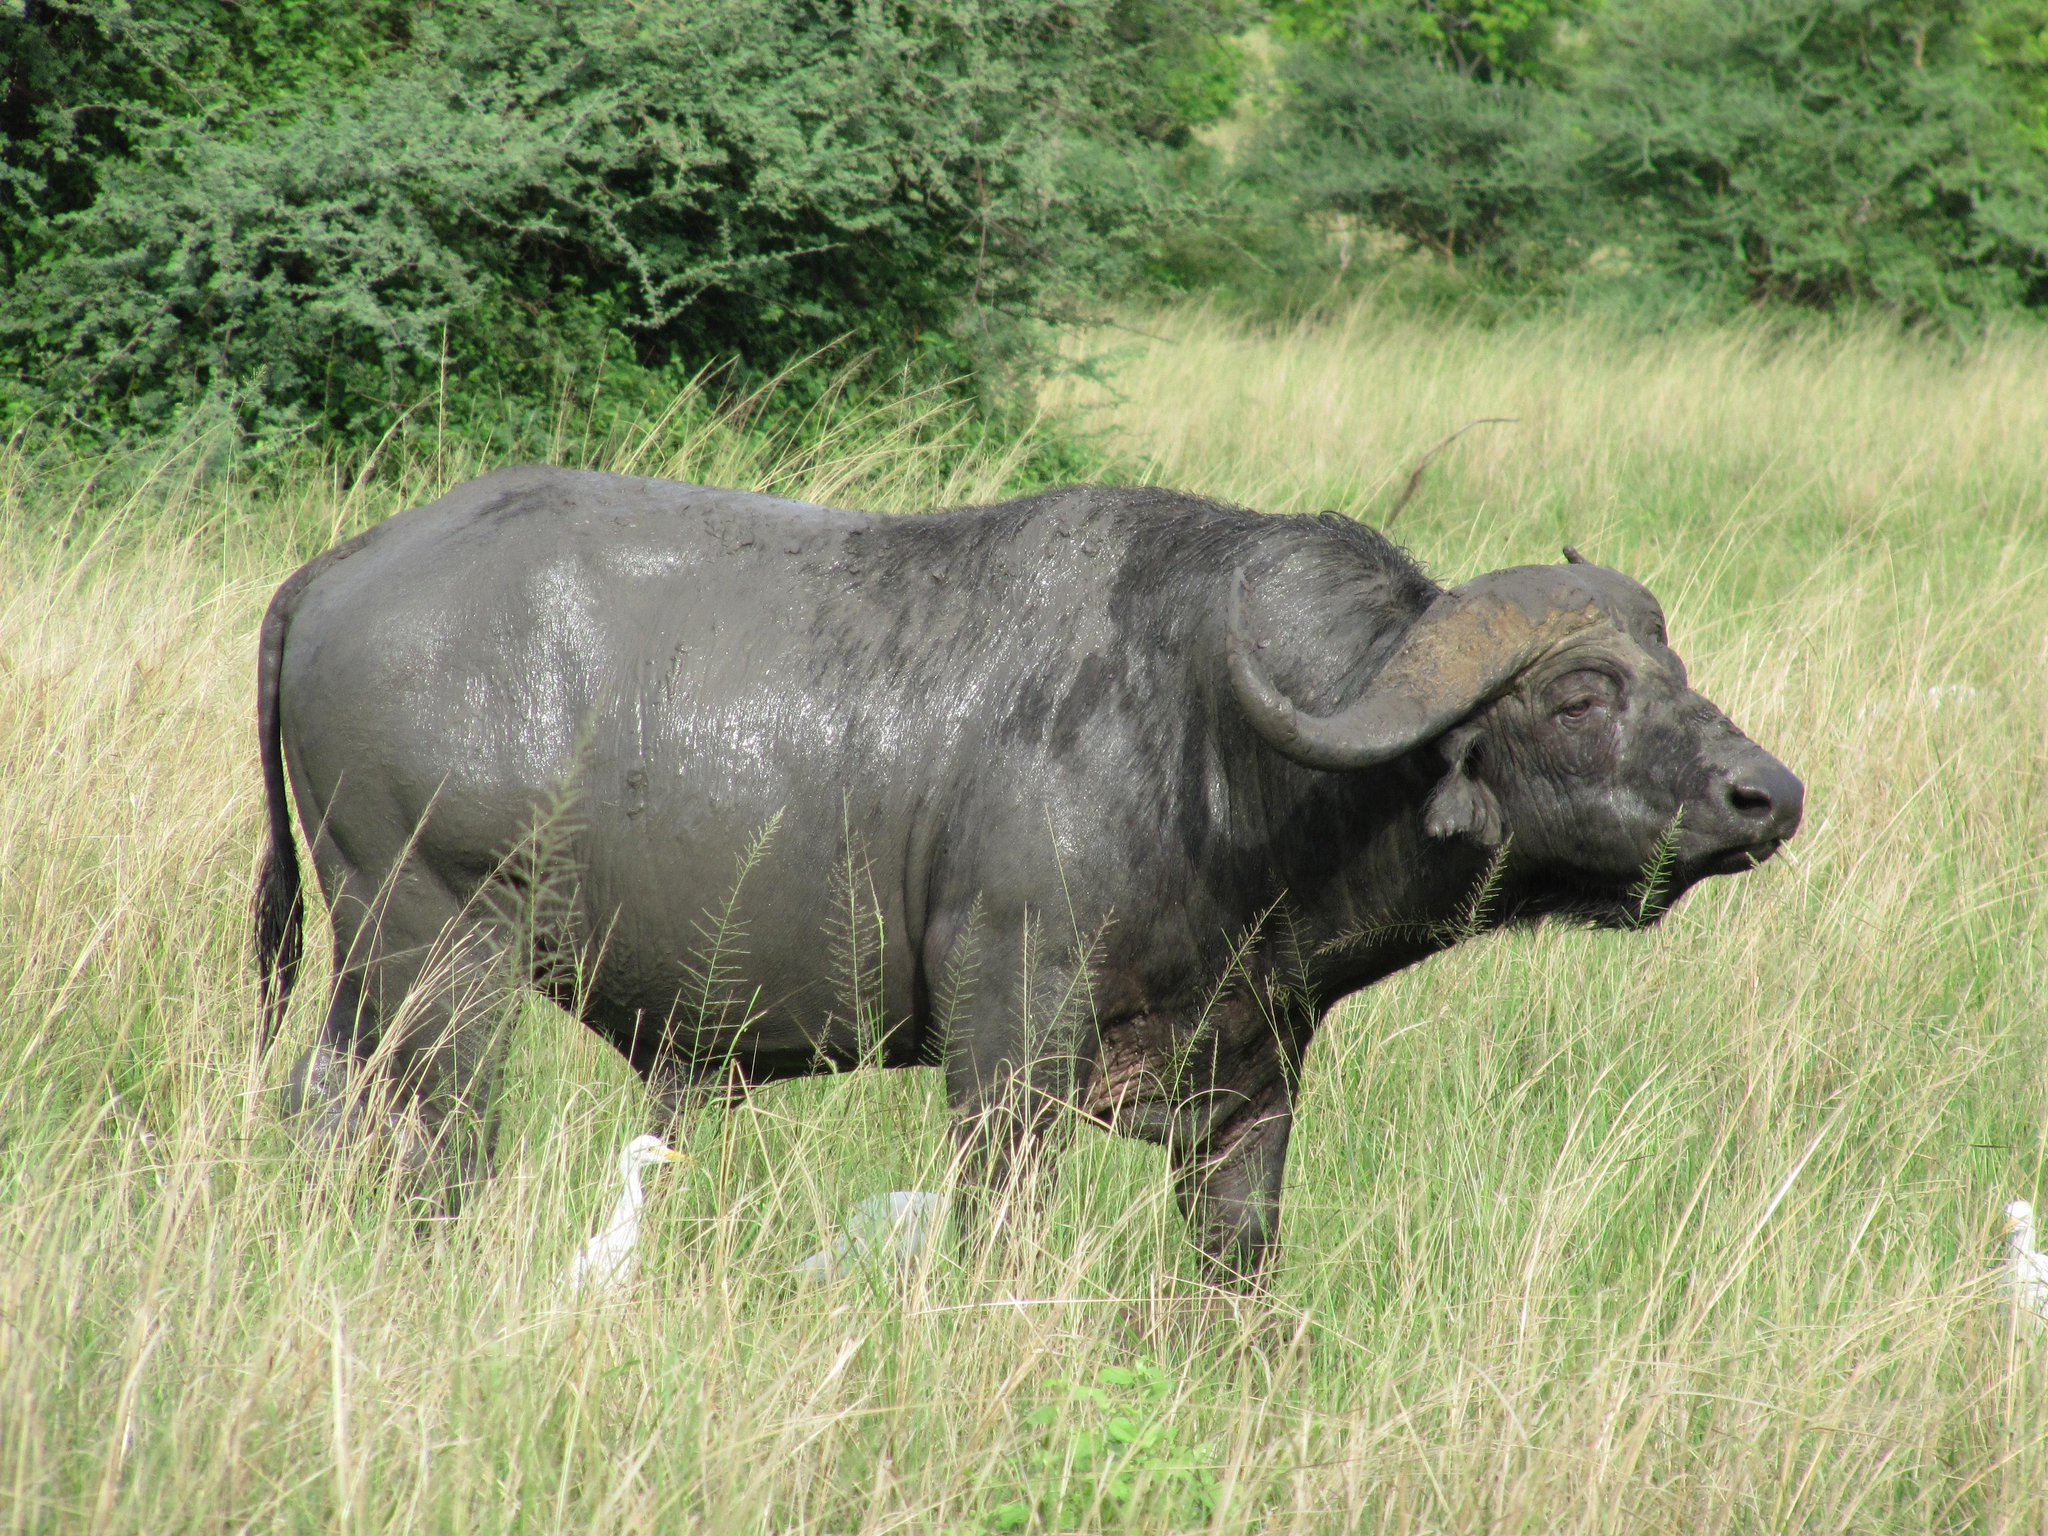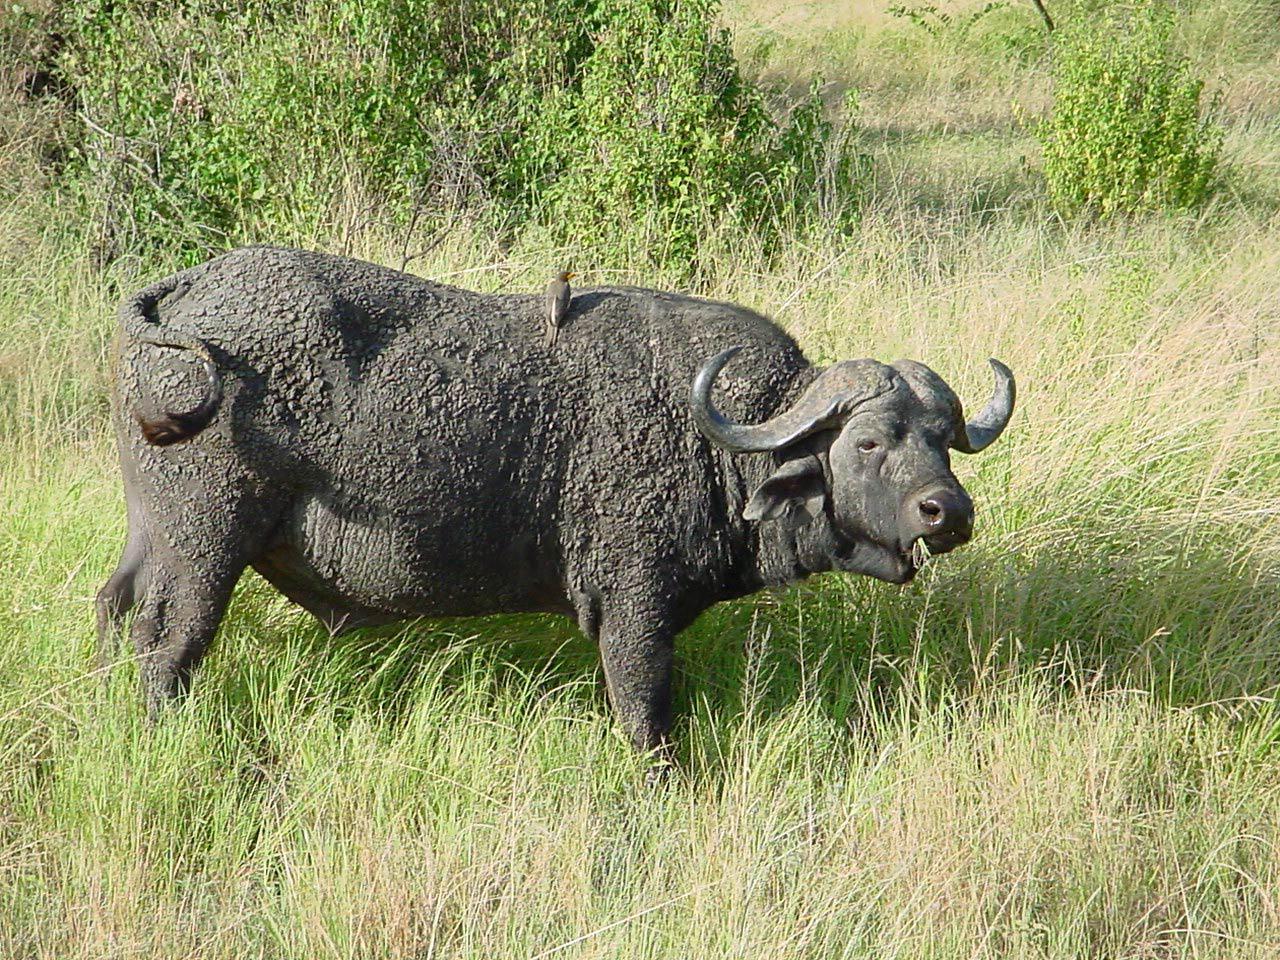The first image is the image on the left, the second image is the image on the right. Examine the images to the left and right. Is the description "The bull on the left image is facing left." accurate? Answer yes or no. No. 